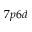<formula> <loc_0><loc_0><loc_500><loc_500>7 p 6 d</formula> 